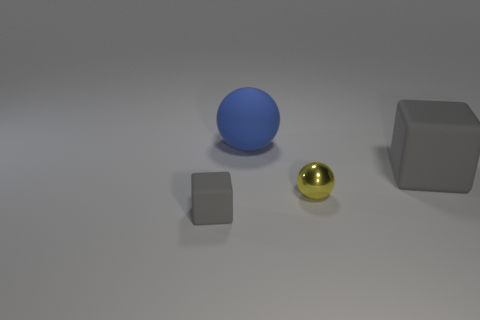Add 2 large objects. How many objects exist? 6 Subtract 1 blocks. How many blocks are left? 1 Subtract all yellow balls. How many balls are left? 1 Subtract 0 brown cylinders. How many objects are left? 4 Subtract all yellow cubes. Subtract all blue spheres. How many cubes are left? 2 Subtract all gray blocks. How many blue spheres are left? 1 Subtract all gray matte things. Subtract all yellow objects. How many objects are left? 1 Add 1 blue rubber balls. How many blue rubber balls are left? 2 Add 2 small brown rubber blocks. How many small brown rubber blocks exist? 2 